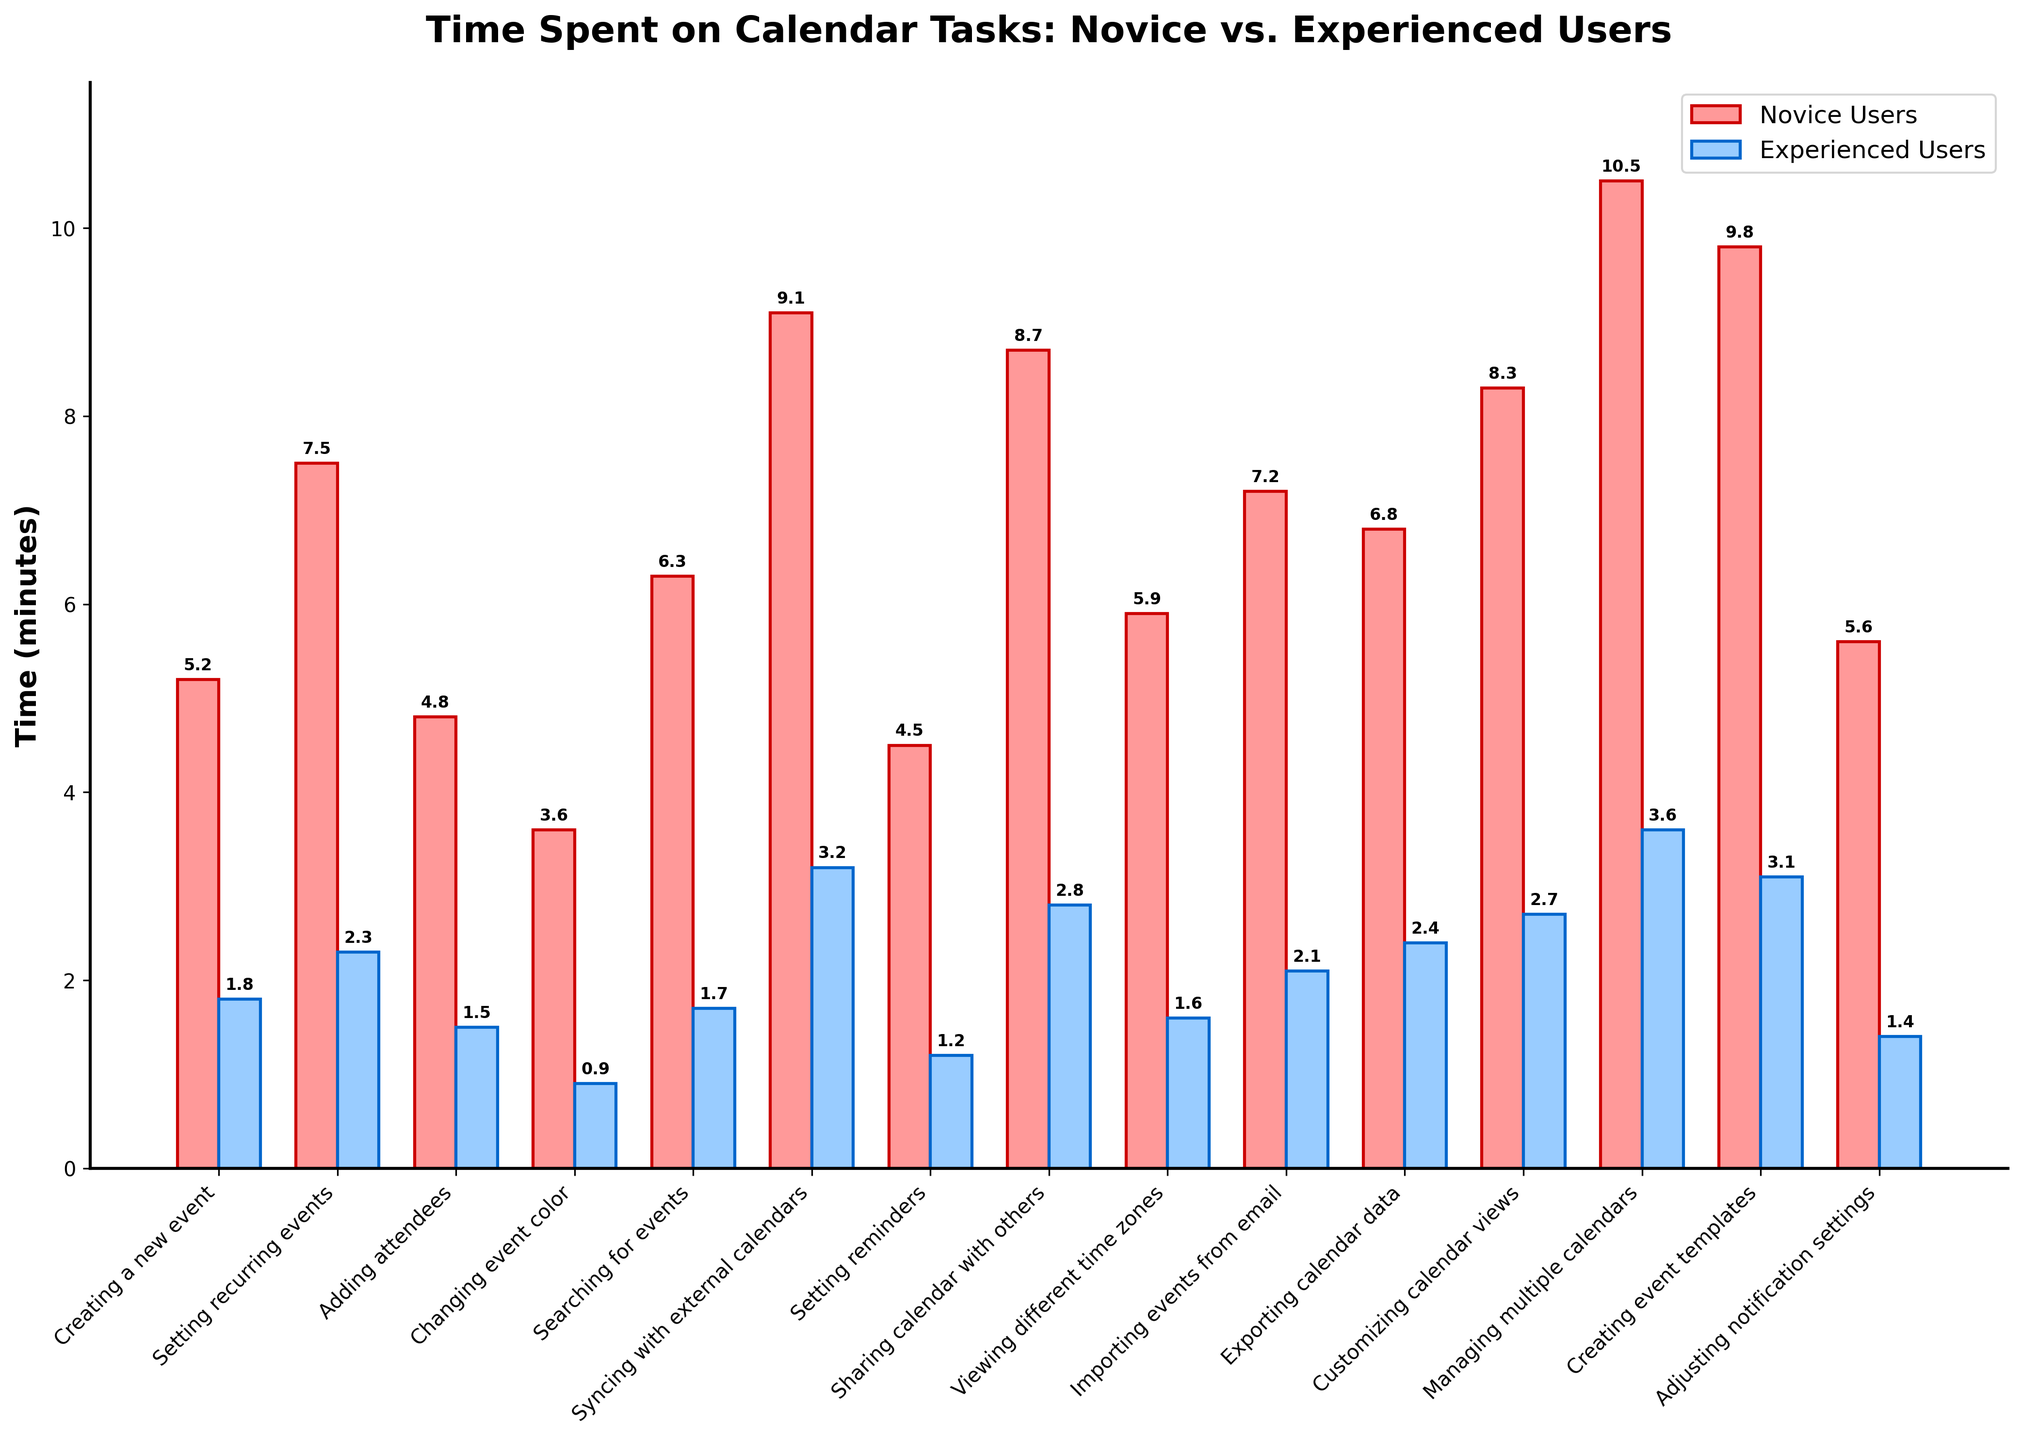Which task takes the longest for novice users? To find this, look at the highest bar for the novice users (red bars). The tallest red bar represents "Managing multiple calendars" with a height of 10.5 minutes.
Answer: Managing multiple calendars What is the difference in time spent syncing with external calendars between novice and experienced users? For novice users, syncing with external calendars takes 9.1 minutes, and for experienced users, it takes 3.2 minutes. The difference is 9.1 - 3.2 = 5.9 minutes.
Answer: 5.9 minutes Which task shows the smallest time difference between novice and experienced users? Compare the differences in time for each task. "Changing event color" shows the smallest difference: 3.6 (novice) - 0.9 (experienced) = 2.7 minutes.
Answer: Changing event color Among all tasks, which one do experienced users complete the quickest? Identify the shortest blue bar (representing experienced users). The shortest blue bar is "Changing event color" with 0.9 minutes.
Answer: Changing event color On average, how much more time do novice users spend on tasks compared to experienced users? Find the average time spent by novice and experienced users, then compute the difference. (5.2+7.5+4.8+3.6+6.3+9.1+4.5+8.7+5.9+7.2+6.8+8.3+10.5+9.8+5.6)/15 = 6.8 (novice), (1.8+2.3+1.5+0.9+1.7+3.2+1.2+2.8+1.6+2.1+2.4+2.7+3.6+3.1+1.4)/15 = 2.2 (experienced). The difference is 6.8 - 2.2 = 4.6 minutes.
Answer: 4.6 minutes For which tasks do novice users spend more than twice the time experienced users spend? Check each task to see if the time for novice users is more than twice that for experienced users. Tasks fitting this criterion are "Setting reminders" (4.5/1.2 > 2), "Sharing calendar with others" (8.7/2.8 > 2), and "Setting recurring events" (7.5/2.3 > 2).
Answer: Setting reminders, Sharing calendar with others, Setting recurring events Are there any tasks where both novice and experienced users spend almost the same amount of time? Look for tasks where the time difference between novice and experienced users is minimal. "Changing event color" (3.6 vs 0.9) and "Viewing different time zones" (5.9 vs 1.6) have relatively small differences but not almost the same.
Answer: No 